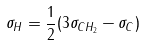Convert formula to latex. <formula><loc_0><loc_0><loc_500><loc_500>\sigma _ { H } = \frac { 1 } { 2 } ( 3 \sigma _ { C H _ { 2 } } - \sigma _ { C } )</formula> 